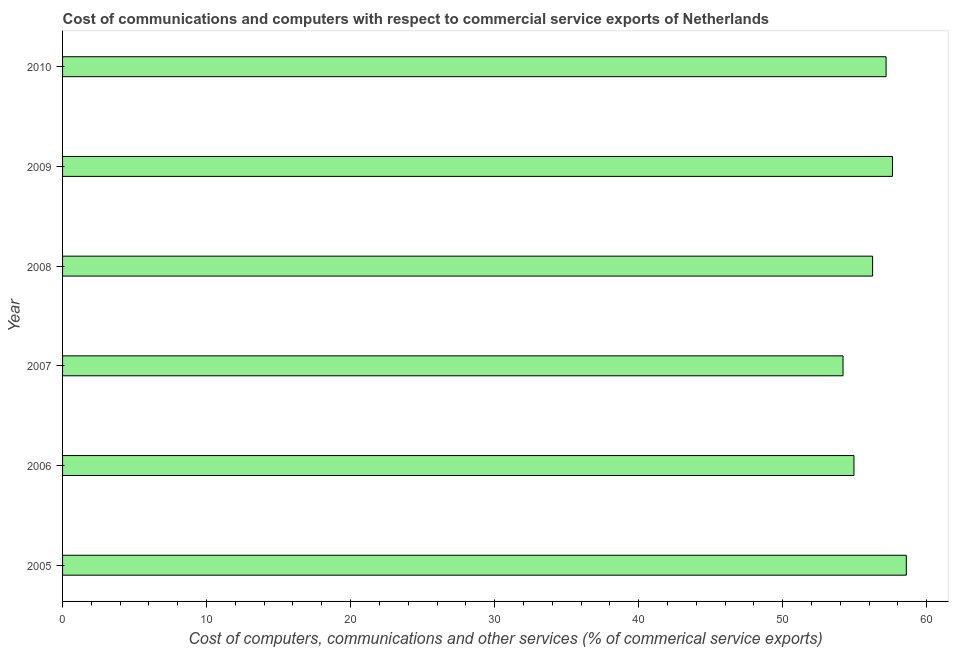Does the graph contain any zero values?
Offer a very short reply. No. What is the title of the graph?
Offer a very short reply. Cost of communications and computers with respect to commercial service exports of Netherlands. What is the label or title of the X-axis?
Make the answer very short. Cost of computers, communications and other services (% of commerical service exports). What is the label or title of the Y-axis?
Offer a terse response. Year. What is the  computer and other services in 2007?
Your response must be concise. 54.19. Across all years, what is the maximum cost of communications?
Offer a very short reply. 58.59. Across all years, what is the minimum cost of communications?
Your answer should be very brief. 54.19. What is the sum of the cost of communications?
Provide a short and direct response. 338.79. What is the difference between the cost of communications in 2005 and 2008?
Your answer should be very brief. 2.34. What is the average  computer and other services per year?
Provide a short and direct response. 56.47. What is the median cost of communications?
Give a very brief answer. 56.72. What is the ratio of the cost of communications in 2005 to that in 2007?
Make the answer very short. 1.08. Is the difference between the  computer and other services in 2005 and 2007 greater than the difference between any two years?
Give a very brief answer. Yes. What is the difference between the highest and the lowest cost of communications?
Offer a terse response. 4.39. How many bars are there?
Make the answer very short. 6. Are all the bars in the graph horizontal?
Your answer should be very brief. Yes. What is the difference between two consecutive major ticks on the X-axis?
Keep it short and to the point. 10. What is the Cost of computers, communications and other services (% of commerical service exports) in 2005?
Keep it short and to the point. 58.59. What is the Cost of computers, communications and other services (% of commerical service exports) in 2006?
Ensure brevity in your answer.  54.95. What is the Cost of computers, communications and other services (% of commerical service exports) of 2007?
Give a very brief answer. 54.19. What is the Cost of computers, communications and other services (% of commerical service exports) in 2008?
Keep it short and to the point. 56.25. What is the Cost of computers, communications and other services (% of commerical service exports) of 2009?
Provide a short and direct response. 57.63. What is the Cost of computers, communications and other services (% of commerical service exports) in 2010?
Your answer should be compact. 57.18. What is the difference between the Cost of computers, communications and other services (% of commerical service exports) in 2005 and 2006?
Your answer should be very brief. 3.64. What is the difference between the Cost of computers, communications and other services (% of commerical service exports) in 2005 and 2007?
Provide a short and direct response. 4.39. What is the difference between the Cost of computers, communications and other services (% of commerical service exports) in 2005 and 2008?
Offer a terse response. 2.34. What is the difference between the Cost of computers, communications and other services (% of commerical service exports) in 2005 and 2009?
Your response must be concise. 0.96. What is the difference between the Cost of computers, communications and other services (% of commerical service exports) in 2005 and 2010?
Your answer should be compact. 1.4. What is the difference between the Cost of computers, communications and other services (% of commerical service exports) in 2006 and 2007?
Offer a very short reply. 0.76. What is the difference between the Cost of computers, communications and other services (% of commerical service exports) in 2006 and 2008?
Keep it short and to the point. -1.3. What is the difference between the Cost of computers, communications and other services (% of commerical service exports) in 2006 and 2009?
Provide a succinct answer. -2.67. What is the difference between the Cost of computers, communications and other services (% of commerical service exports) in 2006 and 2010?
Your response must be concise. -2.23. What is the difference between the Cost of computers, communications and other services (% of commerical service exports) in 2007 and 2008?
Your answer should be very brief. -2.05. What is the difference between the Cost of computers, communications and other services (% of commerical service exports) in 2007 and 2009?
Provide a succinct answer. -3.43. What is the difference between the Cost of computers, communications and other services (% of commerical service exports) in 2007 and 2010?
Give a very brief answer. -2.99. What is the difference between the Cost of computers, communications and other services (% of commerical service exports) in 2008 and 2009?
Your answer should be very brief. -1.38. What is the difference between the Cost of computers, communications and other services (% of commerical service exports) in 2008 and 2010?
Ensure brevity in your answer.  -0.94. What is the difference between the Cost of computers, communications and other services (% of commerical service exports) in 2009 and 2010?
Make the answer very short. 0.44. What is the ratio of the Cost of computers, communications and other services (% of commerical service exports) in 2005 to that in 2006?
Your answer should be very brief. 1.07. What is the ratio of the Cost of computers, communications and other services (% of commerical service exports) in 2005 to that in 2007?
Your answer should be compact. 1.08. What is the ratio of the Cost of computers, communications and other services (% of commerical service exports) in 2005 to that in 2008?
Make the answer very short. 1.04. What is the ratio of the Cost of computers, communications and other services (% of commerical service exports) in 2005 to that in 2009?
Keep it short and to the point. 1.02. What is the ratio of the Cost of computers, communications and other services (% of commerical service exports) in 2006 to that in 2007?
Keep it short and to the point. 1.01. What is the ratio of the Cost of computers, communications and other services (% of commerical service exports) in 2006 to that in 2009?
Offer a terse response. 0.95. What is the ratio of the Cost of computers, communications and other services (% of commerical service exports) in 2006 to that in 2010?
Give a very brief answer. 0.96. What is the ratio of the Cost of computers, communications and other services (% of commerical service exports) in 2007 to that in 2008?
Give a very brief answer. 0.96. What is the ratio of the Cost of computers, communications and other services (% of commerical service exports) in 2007 to that in 2010?
Make the answer very short. 0.95. What is the ratio of the Cost of computers, communications and other services (% of commerical service exports) in 2008 to that in 2009?
Provide a short and direct response. 0.98. 